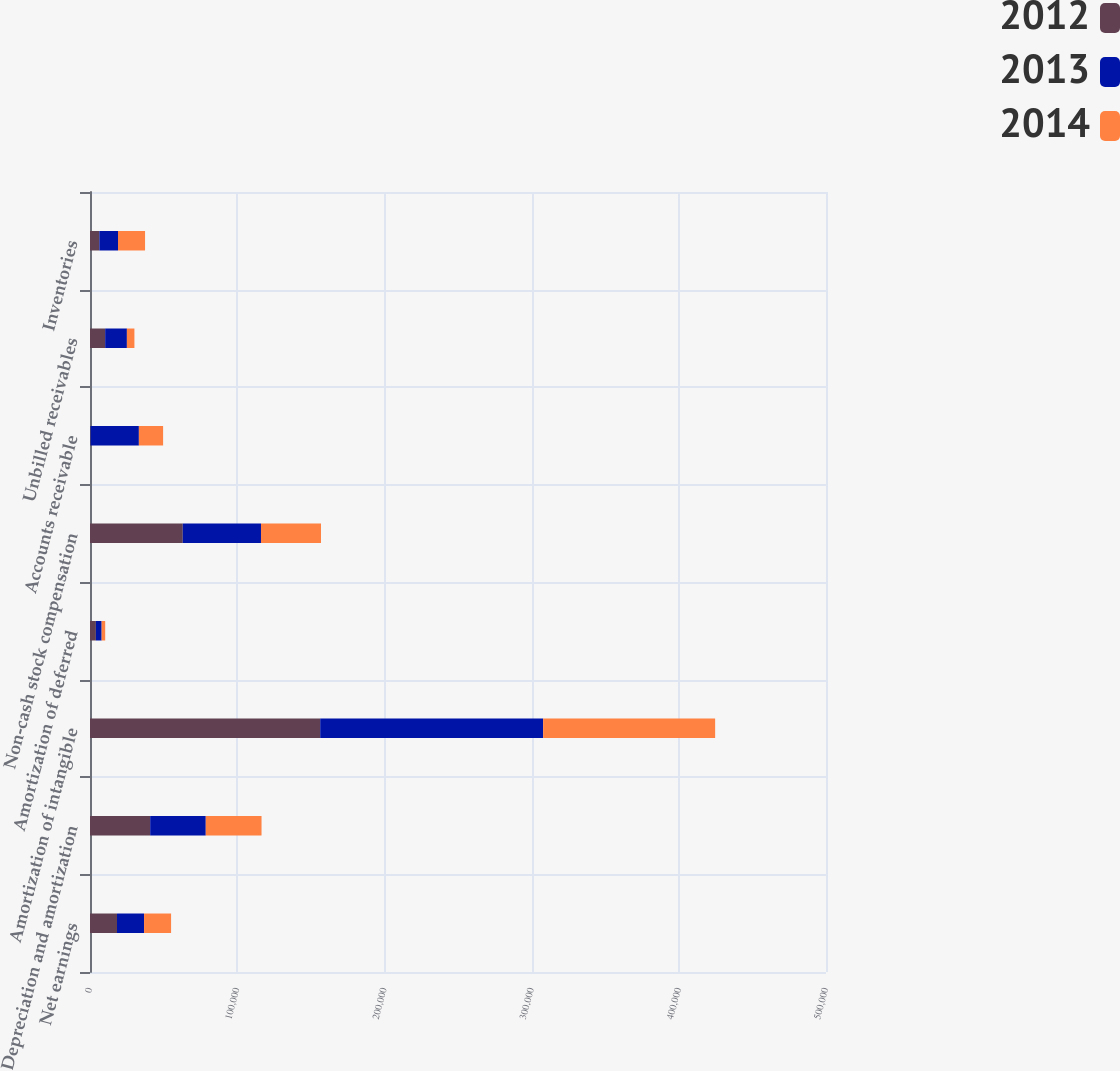Convert chart. <chart><loc_0><loc_0><loc_500><loc_500><stacked_bar_chart><ecel><fcel>Net earnings<fcel>Depreciation and amortization<fcel>Amortization of intangible<fcel>Amortization of deferred<fcel>Non-cash stock compensation<fcel>Accounts receivable<fcel>Unbilled receivables<fcel>Inventories<nl><fcel>2012<fcel>18361<fcel>40890<fcel>156394<fcel>4003<fcel>63027<fcel>404<fcel>10305<fcel>6349<nl><fcel>2013<fcel>18361<fcel>37756<fcel>151434<fcel>3918<fcel>53133<fcel>32800<fcel>14754<fcel>12687<nl><fcel>2014<fcel>18361<fcel>37888<fcel>116860<fcel>2399<fcel>40773<fcel>16455<fcel>5122<fcel>18361<nl></chart> 